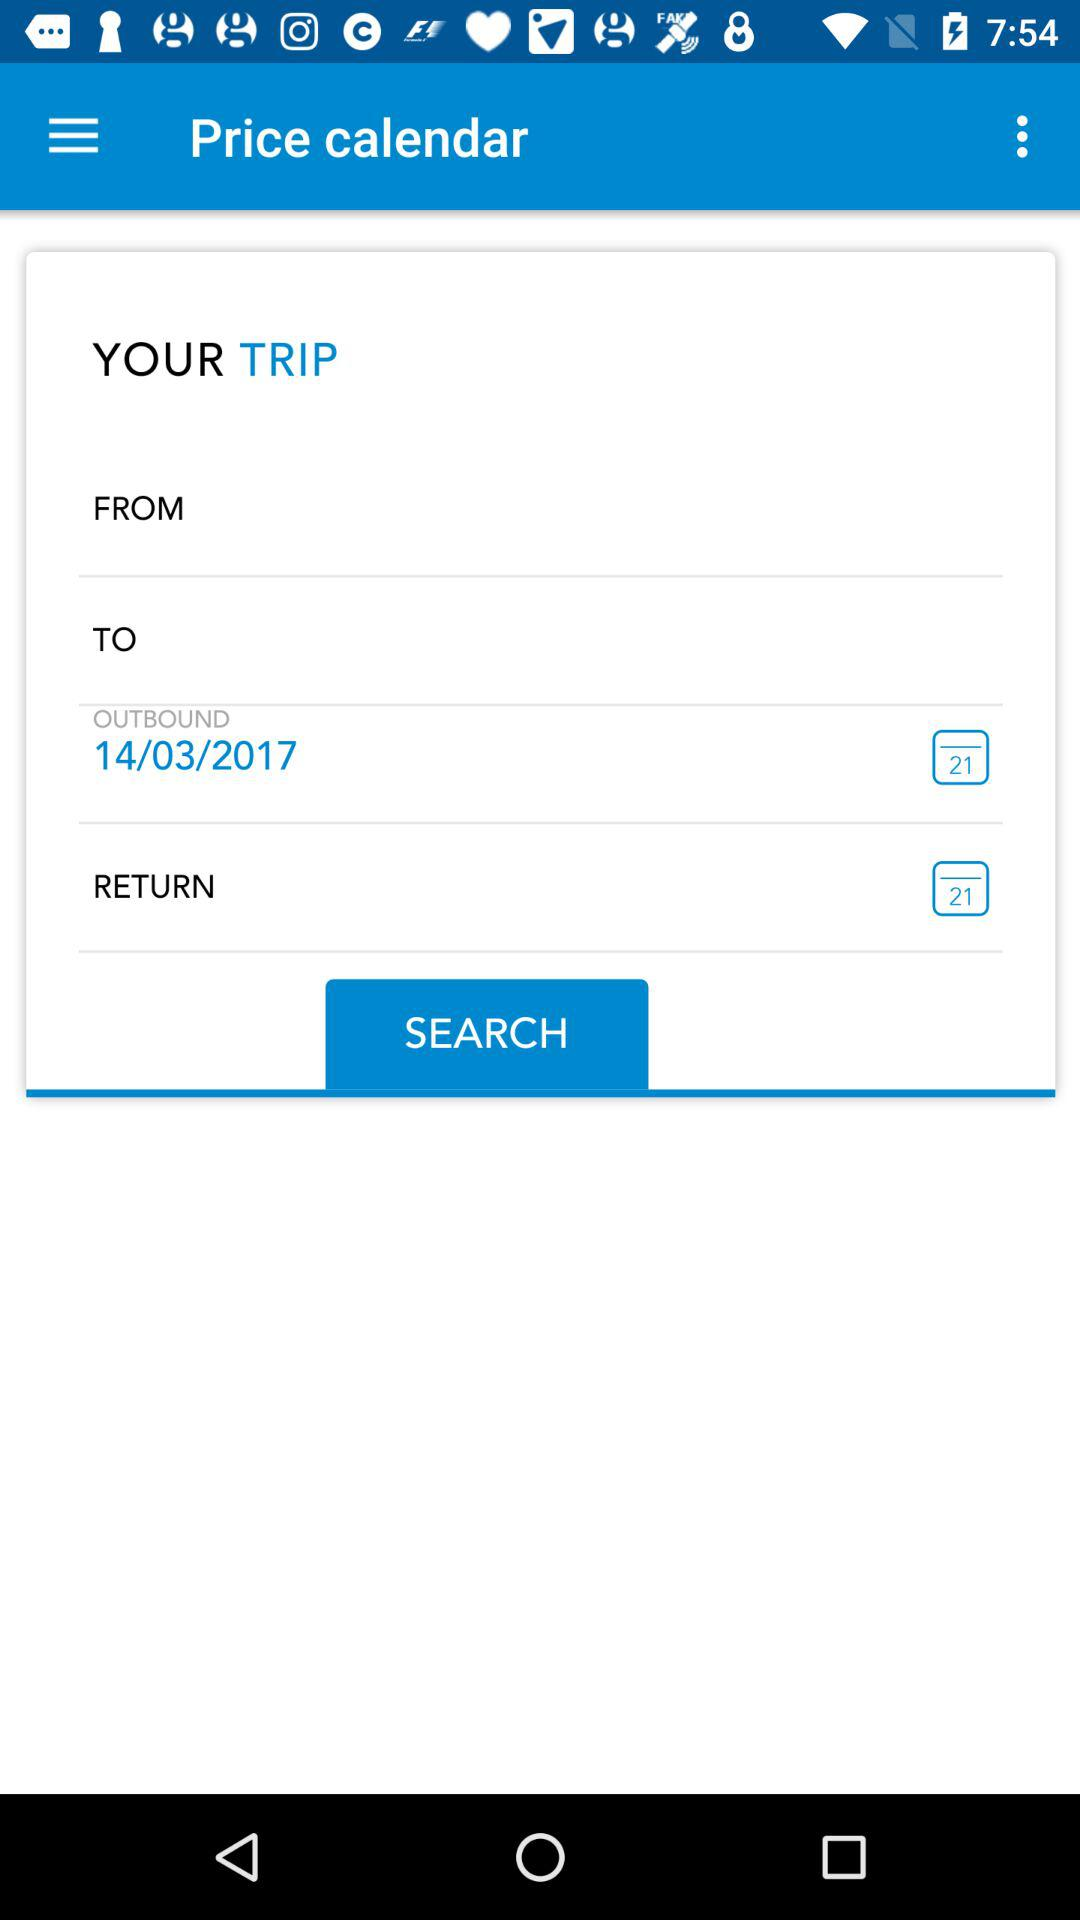What is the outbound date? The outbound date is 14/03/2017. 